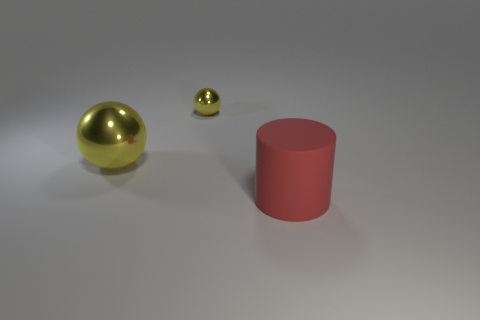Can you describe the lighting and shadows in the image? The lighting in the image appears to be coming from above, casting soft-edged shadows that fan out from the objects. The shadows suggest that the light source is not directly overhead but possibly at a slight angle, given the length and direction of the shadows. 